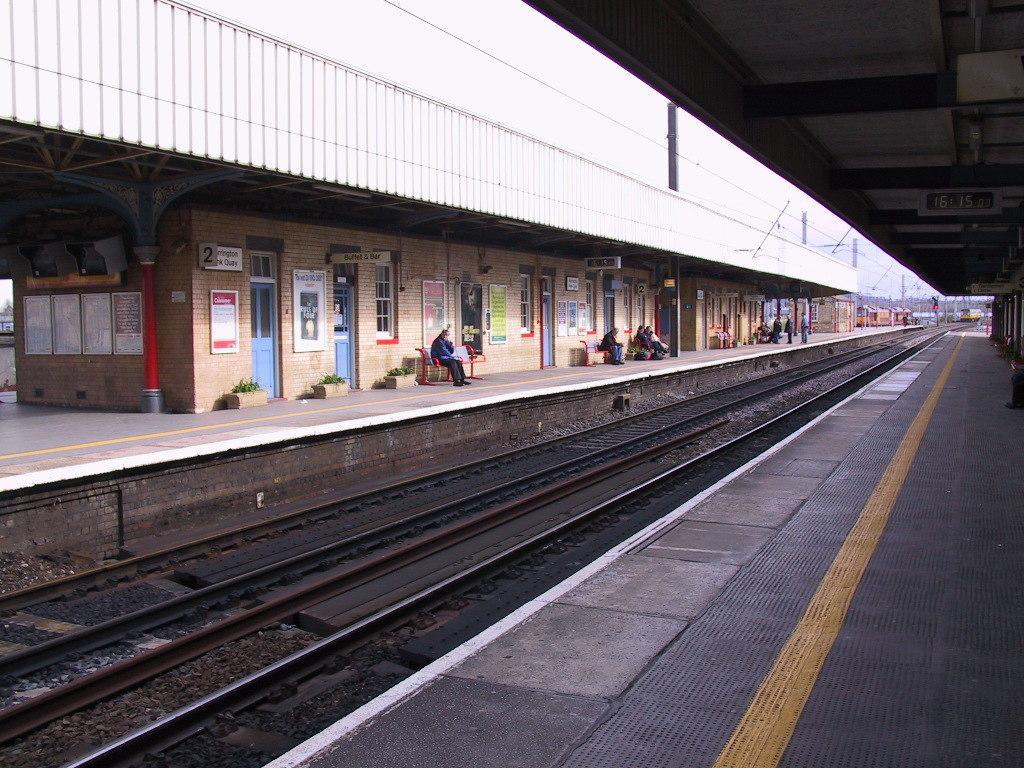Please provide a concise description of this image. This is a railway station. Hear I can see the railway tracks on the ground. On both sides I can see the platform. There are few people sitting on the benches on the platform and also I can see some plants. In the background, I can see a train. 